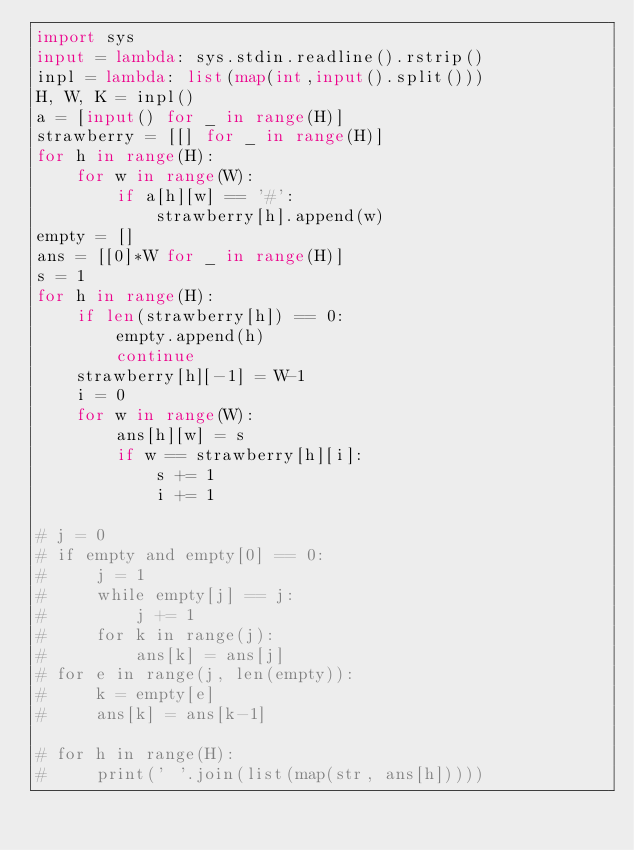Convert code to text. <code><loc_0><loc_0><loc_500><loc_500><_Python_>import sys
input = lambda: sys.stdin.readline().rstrip()
inpl = lambda: list(map(int,input().split()))
H, W, K = inpl()
a = [input() for _ in range(H)]
strawberry = [[] for _ in range(H)]
for h in range(H):
    for w in range(W):
        if a[h][w] == '#':
            strawberry[h].append(w)
empty = []
ans = [[0]*W for _ in range(H)]
s = 1
for h in range(H):
    if len(strawberry[h]) == 0:
        empty.append(h)
        continue
    strawberry[h][-1] = W-1
    i = 0
    for w in range(W):
        ans[h][w] = s
        if w == strawberry[h][i]:
            s += 1
            i += 1

# j = 0
# if empty and empty[0] == 0:
#     j = 1
#     while empty[j] == j:
#         j += 1
#     for k in range(j):
#         ans[k] = ans[j]
# for e in range(j, len(empty)):
#     k = empty[e]
#     ans[k] = ans[k-1]

# for h in range(H):
#     print(' '.join(list(map(str, ans[h]))))
</code> 